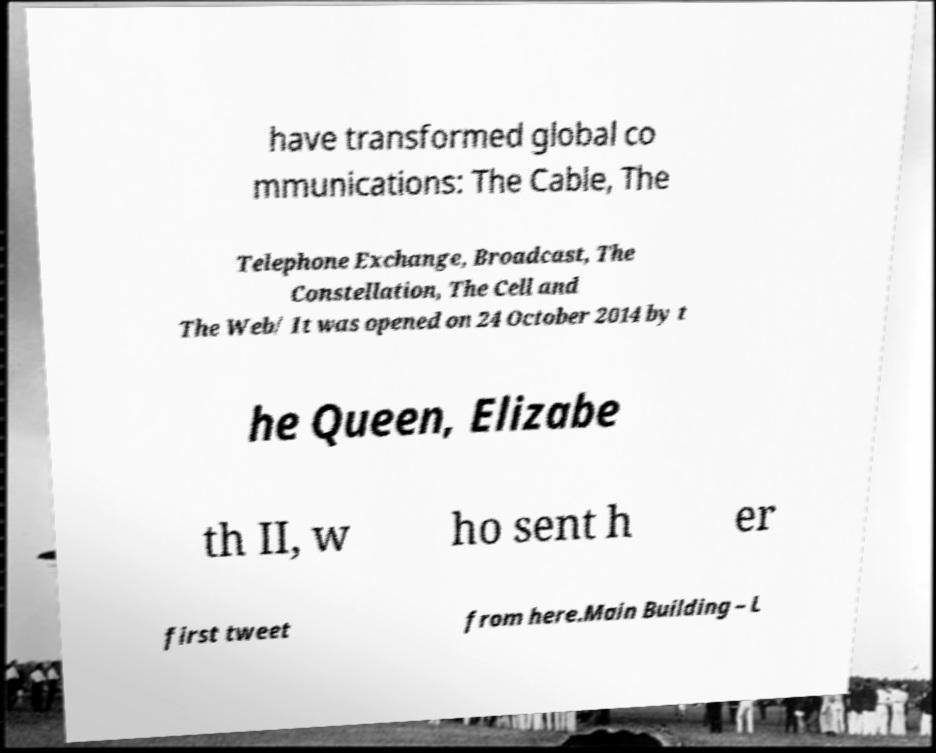What messages or text are displayed in this image? I need them in a readable, typed format. have transformed global co mmunications: The Cable, The Telephone Exchange, Broadcast, The Constellation, The Cell and The Web/ It was opened on 24 October 2014 by t he Queen, Elizabe th II, w ho sent h er first tweet from here.Main Building – L 